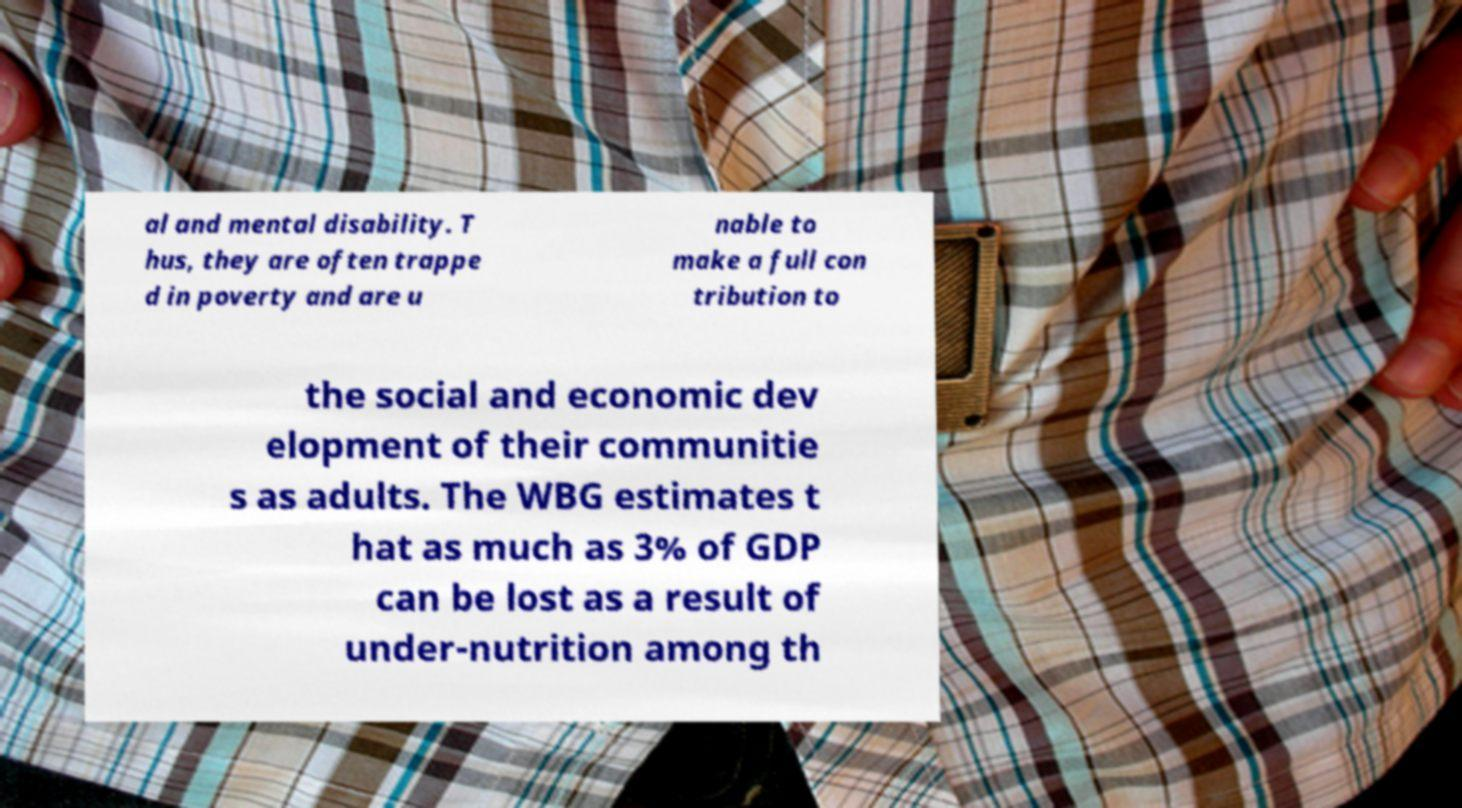What messages or text are displayed in this image? I need them in a readable, typed format. al and mental disability. T hus, they are often trappe d in poverty and are u nable to make a full con tribution to the social and economic dev elopment of their communitie s as adults. The WBG estimates t hat as much as 3% of GDP can be lost as a result of under-nutrition among th 